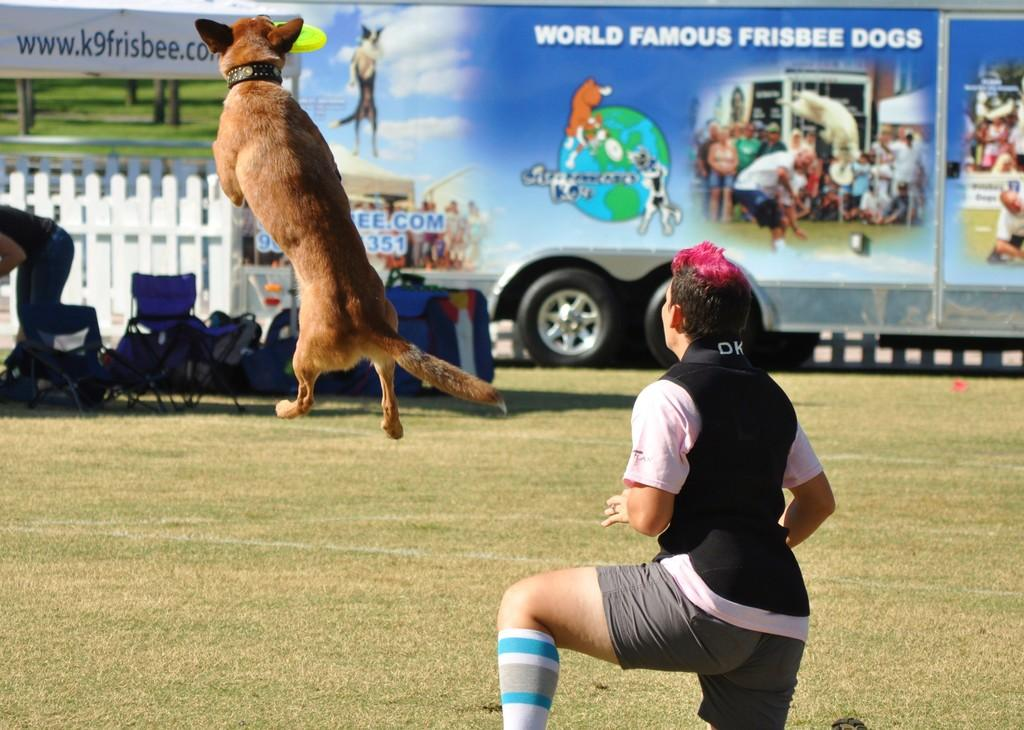What is the position of the person in the image? There is a person sitting on the ground. What is the dog doing in the image? A dog is jumping in the air. What can be seen in the background of the image? There are chairs, luggage, and a vehicle in the background. How many coils can be seen on the person's toes in the image? There are no coils visible on the person's toes in the image, as the person is sitting on the ground and their feet are not shown. 